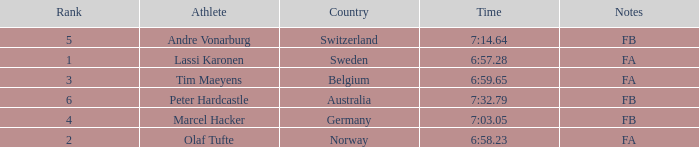Which athlete is from Norway? Olaf Tufte. 